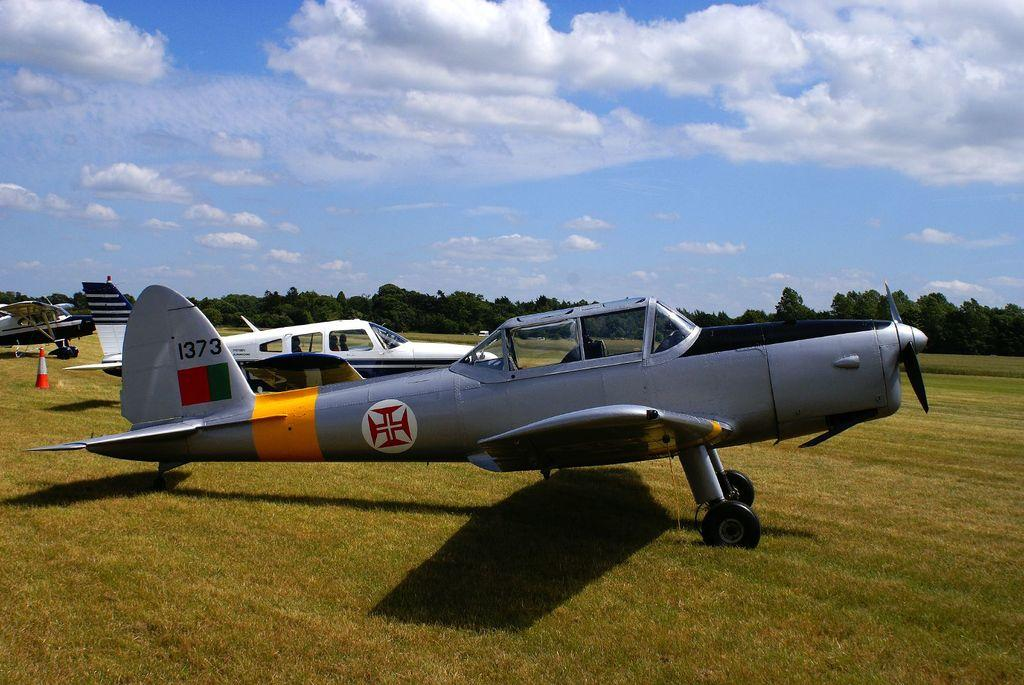<image>
Provide a brief description of the given image. An old aeroplane with the number 1373 on its tail 